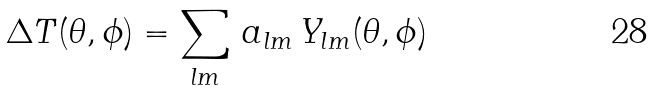<formula> <loc_0><loc_0><loc_500><loc_500>\Delta T ( \theta , \phi ) = \sum _ { l m } \, a _ { l m } \, Y _ { l m } ( \theta , \phi )</formula> 